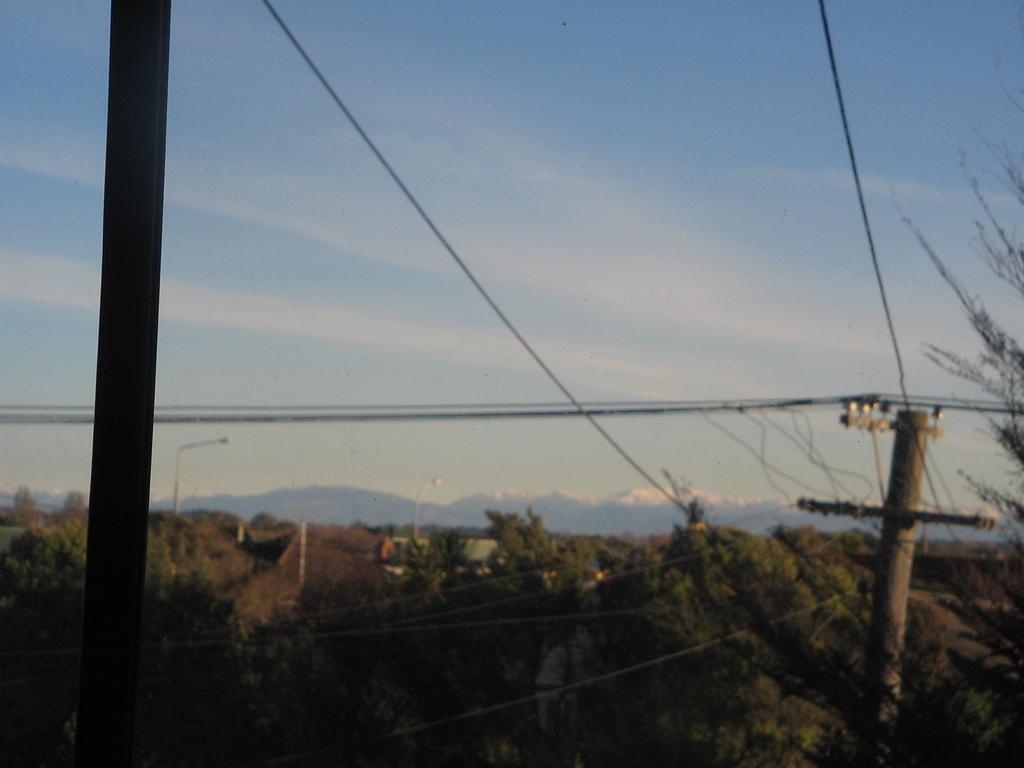In one or two sentences, can you explain what this image depicts? In this image I see number of poles and I see the wires and I see number of trees. In the background I see the sky. 